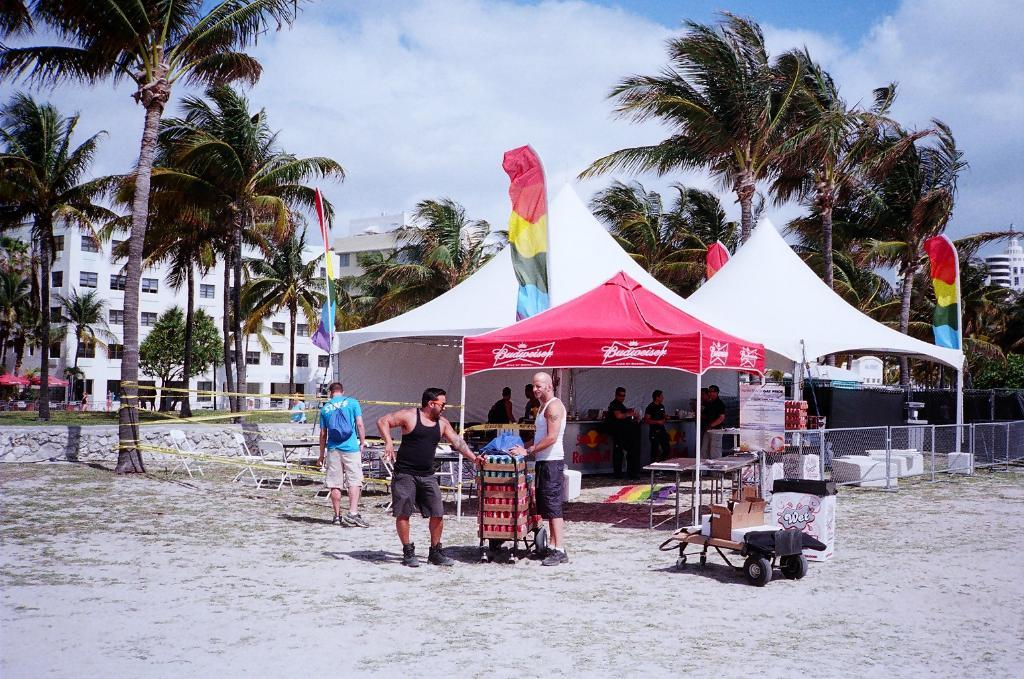What is located in the center of the image? There are tents and persons in the center of the image. What can be seen in the background of the image? There are trees, buildings, the sky, and clouds visible in the background of the image. What type of terrain is at the bottom of the image? There is sand at the bottom of the image. Can you see any ice on the stage in the image? There is no stage or ice present in the image. Is there a rabbit visible in the image? There is no rabbit present in the image. 